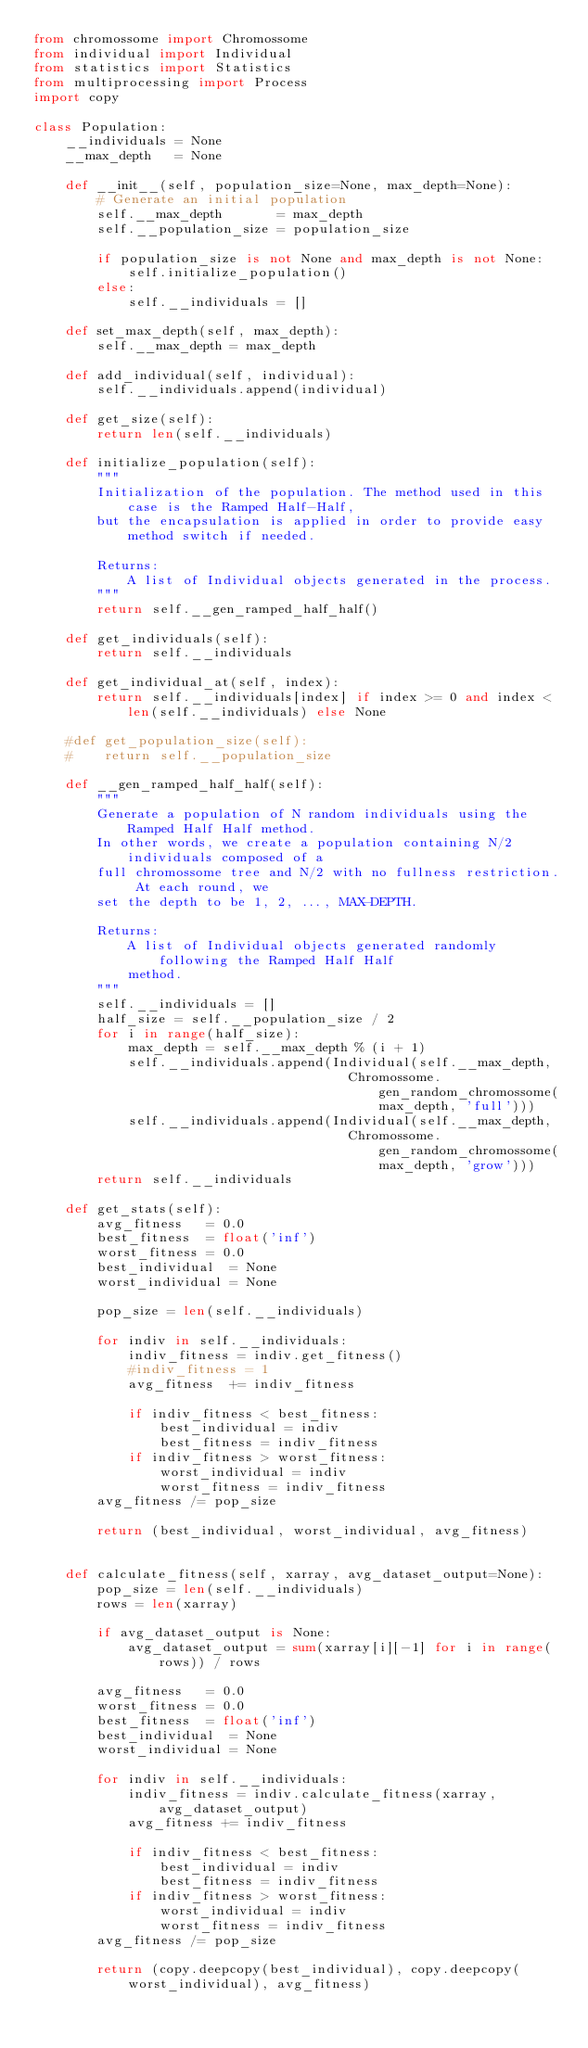Convert code to text. <code><loc_0><loc_0><loc_500><loc_500><_Python_>from chromossome import Chromossome
from individual import Individual
from statistics import Statistics
from multiprocessing import Process
import copy

class Population:
    __individuals = None
    __max_depth   = None

    def __init__(self, population_size=None, max_depth=None):
        # Generate an initial population
        self.__max_depth       = max_depth
        self.__population_size = population_size

        if population_size is not None and max_depth is not None:
            self.initialize_population()
        else:
            self.__individuals = []
        
    def set_max_depth(self, max_depth):
        self.__max_depth = max_depth

    def add_individual(self, individual):
        self.__individuals.append(individual)

    def get_size(self):
        return len(self.__individuals)

    def initialize_population(self):
        """
        Initialization of the population. The method used in this case is the Ramped Half-Half,
        but the encapsulation is applied in order to provide easy method switch if needed.

        Returns:
            A list of Individual objects generated in the process.
        """
        return self.__gen_ramped_half_half()

    def get_individuals(self):
        return self.__individuals

    def get_individual_at(self, index):
        return self.__individuals[index] if index >= 0 and index < len(self.__individuals) else None

    #def get_population_size(self):
    #    return self.__population_size

    def __gen_ramped_half_half(self):
        """ 
        Generate a population of N random individuals using the Ramped Half Half method.
        In other words, we create a population containing N/2 individuals composed of a
        full chromossome tree and N/2 with no fullness restriction. At each round, we 
        set the depth to be 1, 2, ..., MAX-DEPTH.

        Returns:
            A list of Individual objects generated randomly following the Ramped Half Half
            method.
        """
        self.__individuals = []
        half_size = self.__population_size / 2
        for i in range(half_size):
            max_depth = self.__max_depth % (i + 1)
            self.__individuals.append(Individual(self.__max_depth, 
                                        Chromossome.gen_random_chromossome(max_depth, 'full')))
            self.__individuals.append(Individual(self.__max_depth, 
                                        Chromossome.gen_random_chromossome(max_depth, 'grow')))
        return self.__individuals

    def get_stats(self):
        avg_fitness   = 0.0
        best_fitness  = float('inf')
        worst_fitness = 0.0
        best_individual  = None
        worst_individual = None

        pop_size = len(self.__individuals)

        for indiv in self.__individuals:
            indiv_fitness = indiv.get_fitness()
            #indiv_fitness = 1
            avg_fitness  += indiv_fitness

            if indiv_fitness < best_fitness:
                best_individual = indiv
                best_fitness = indiv_fitness
            if indiv_fitness > worst_fitness:
                worst_individual = indiv
                worst_fitness = indiv_fitness
        avg_fitness /= pop_size

        return (best_individual, worst_individual, avg_fitness)


    def calculate_fitness(self, xarray, avg_dataset_output=None):
        pop_size = len(self.__individuals)
        rows = len(xarray)

        if avg_dataset_output is None:
            avg_dataset_output = sum(xarray[i][-1] for i in range(rows)) / rows

        avg_fitness   = 0.0
        worst_fitness = 0.0
        best_fitness  = float('inf')
        best_individual  = None
        worst_individual = None

        for indiv in self.__individuals:
            indiv_fitness = indiv.calculate_fitness(xarray, avg_dataset_output)
            avg_fitness += indiv_fitness
                        
            if indiv_fitness < best_fitness:
                best_individual = indiv
                best_fitness = indiv_fitness
            if indiv_fitness > worst_fitness:
                worst_individual = indiv
                worst_fitness = indiv_fitness
        avg_fitness /= pop_size

        return (copy.deepcopy(best_individual), copy.deepcopy(worst_individual), avg_fitness)
</code> 